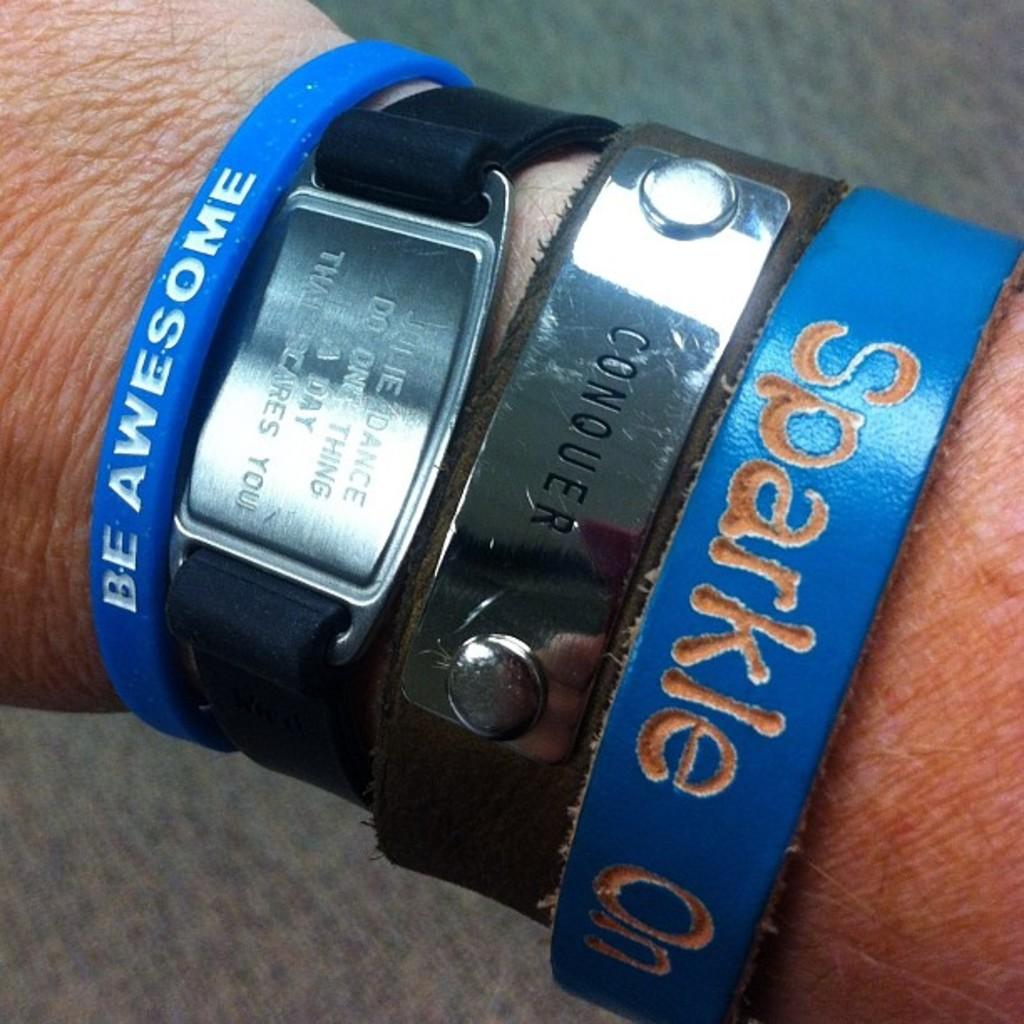<image>
Describe the image concisely. A blue wrist band says to sparkle on. 